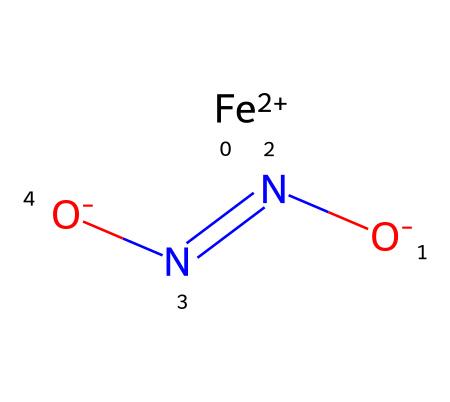What is the oxidation state of iron in this chemical? The iron in this chemical is represented as [Fe+2], indicating that it has an oxidation state of +2.
Answer: +2 How many nitrogen atoms are present in this structure? The SMILES representation contains two nitrogen atoms denoted by N in the molecular structure: 'N=N' indicates two nitrogen atoms are connected by a double bond.
Answer: 2 What type of bond connects the two nitrogen atoms in this chemical? The structure shows 'N=N,' which indicates a double bond between the nitrogen atoms based on the SMILES syntax.
Answer: double bond What role does iron play in this chemical? In the context of hemoglobin, iron binds to oxygen, allowing for its transport throughout the body, including the brain.
Answer: oxygen transport Which elements are present in this chemical? Analyzing the SMILES representation, the elements present include iron (Fe), nitrogen (N), and oxygen (O).
Answer: iron, nitrogen, oxygen What is the net charge of this chemical? The iron is +2 and each of the two oxygens carries a -1 charge, balanced between the metal and the oxygens, resulting in a total net charge of 0.
Answer: 0 Is this chemical protonated or deprotonated? The presence of [O-] in the SMILES indicates that there is a deprotonated oxygen, suggesting that the chemical is in a deprotonated state.
Answer: deprotonated 